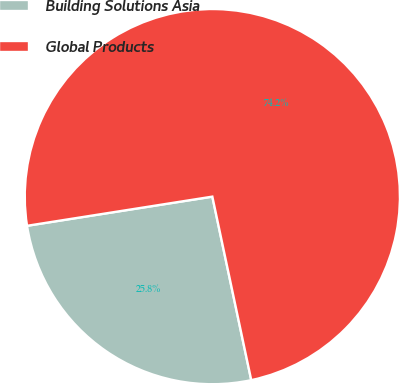Convert chart. <chart><loc_0><loc_0><loc_500><loc_500><pie_chart><fcel>Building Solutions Asia<fcel>Global Products<nl><fcel>25.84%<fcel>74.16%<nl></chart> 